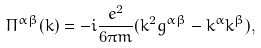Convert formula to latex. <formula><loc_0><loc_0><loc_500><loc_500>\Pi ^ { \alpha \beta } ( k ) = - i \frac { e ^ { 2 } } { 6 \pi m } ( k ^ { 2 } g ^ { \alpha \beta } - k ^ { \alpha } k ^ { \beta } ) ,</formula> 